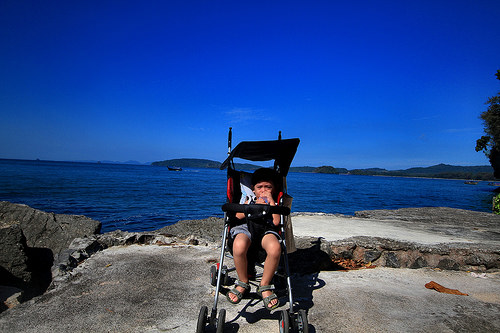<image>
Is the sky behind the baby? Yes. From this viewpoint, the sky is positioned behind the baby, with the baby partially or fully occluding the sky. Where is the kid in relation to the sea? Is it next to the sea? Yes. The kid is positioned adjacent to the sea, located nearby in the same general area. 